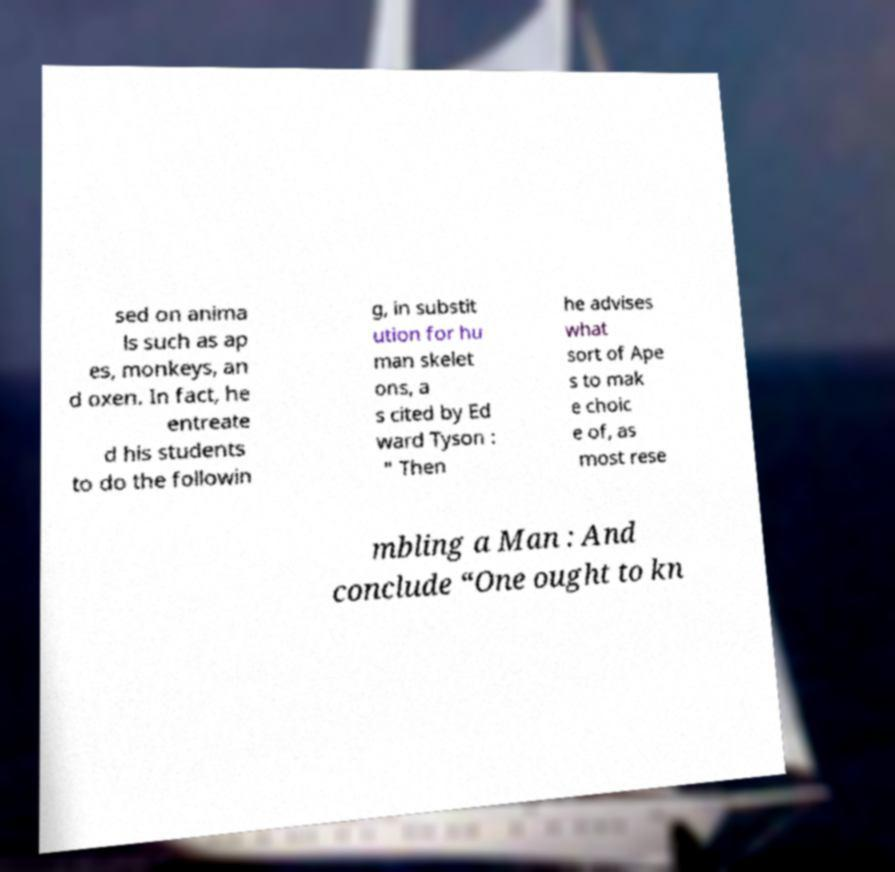Could you assist in decoding the text presented in this image and type it out clearly? sed on anima ls such as ap es, monkeys, an d oxen. In fact, he entreate d his students to do the followin g, in substit ution for hu man skelet ons, a s cited by Ed ward Tyson : " Then he advises what sort of Ape s to mak e choic e of, as most rese mbling a Man : And conclude “One ought to kn 